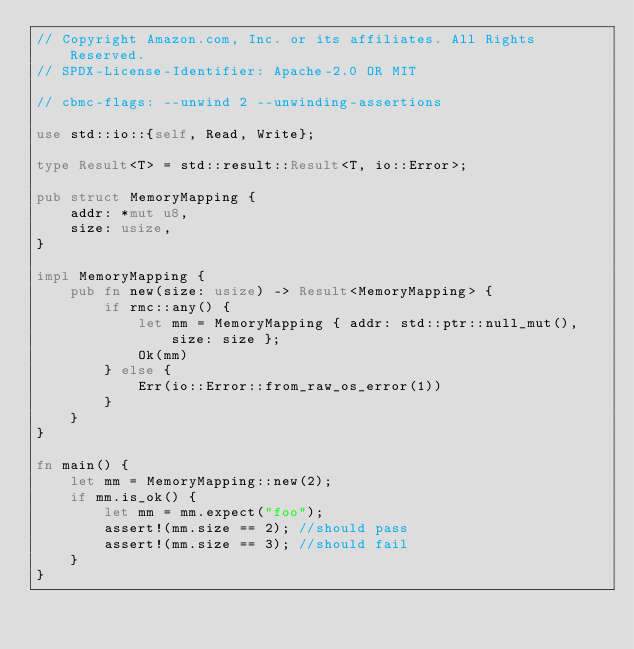Convert code to text. <code><loc_0><loc_0><loc_500><loc_500><_Rust_>// Copyright Amazon.com, Inc. or its affiliates. All Rights Reserved.
// SPDX-License-Identifier: Apache-2.0 OR MIT

// cbmc-flags: --unwind 2 --unwinding-assertions

use std::io::{self, Read, Write};

type Result<T> = std::result::Result<T, io::Error>;

pub struct MemoryMapping {
    addr: *mut u8,
    size: usize,
}

impl MemoryMapping {
    pub fn new(size: usize) -> Result<MemoryMapping> {
        if rmc::any() {
            let mm = MemoryMapping { addr: std::ptr::null_mut(), size: size };
            Ok(mm)
        } else {
            Err(io::Error::from_raw_os_error(1))
        }
    }
}

fn main() {
    let mm = MemoryMapping::new(2);
    if mm.is_ok() {
        let mm = mm.expect("foo");
        assert!(mm.size == 2); //should pass
        assert!(mm.size == 3); //should fail
    }
}
</code> 